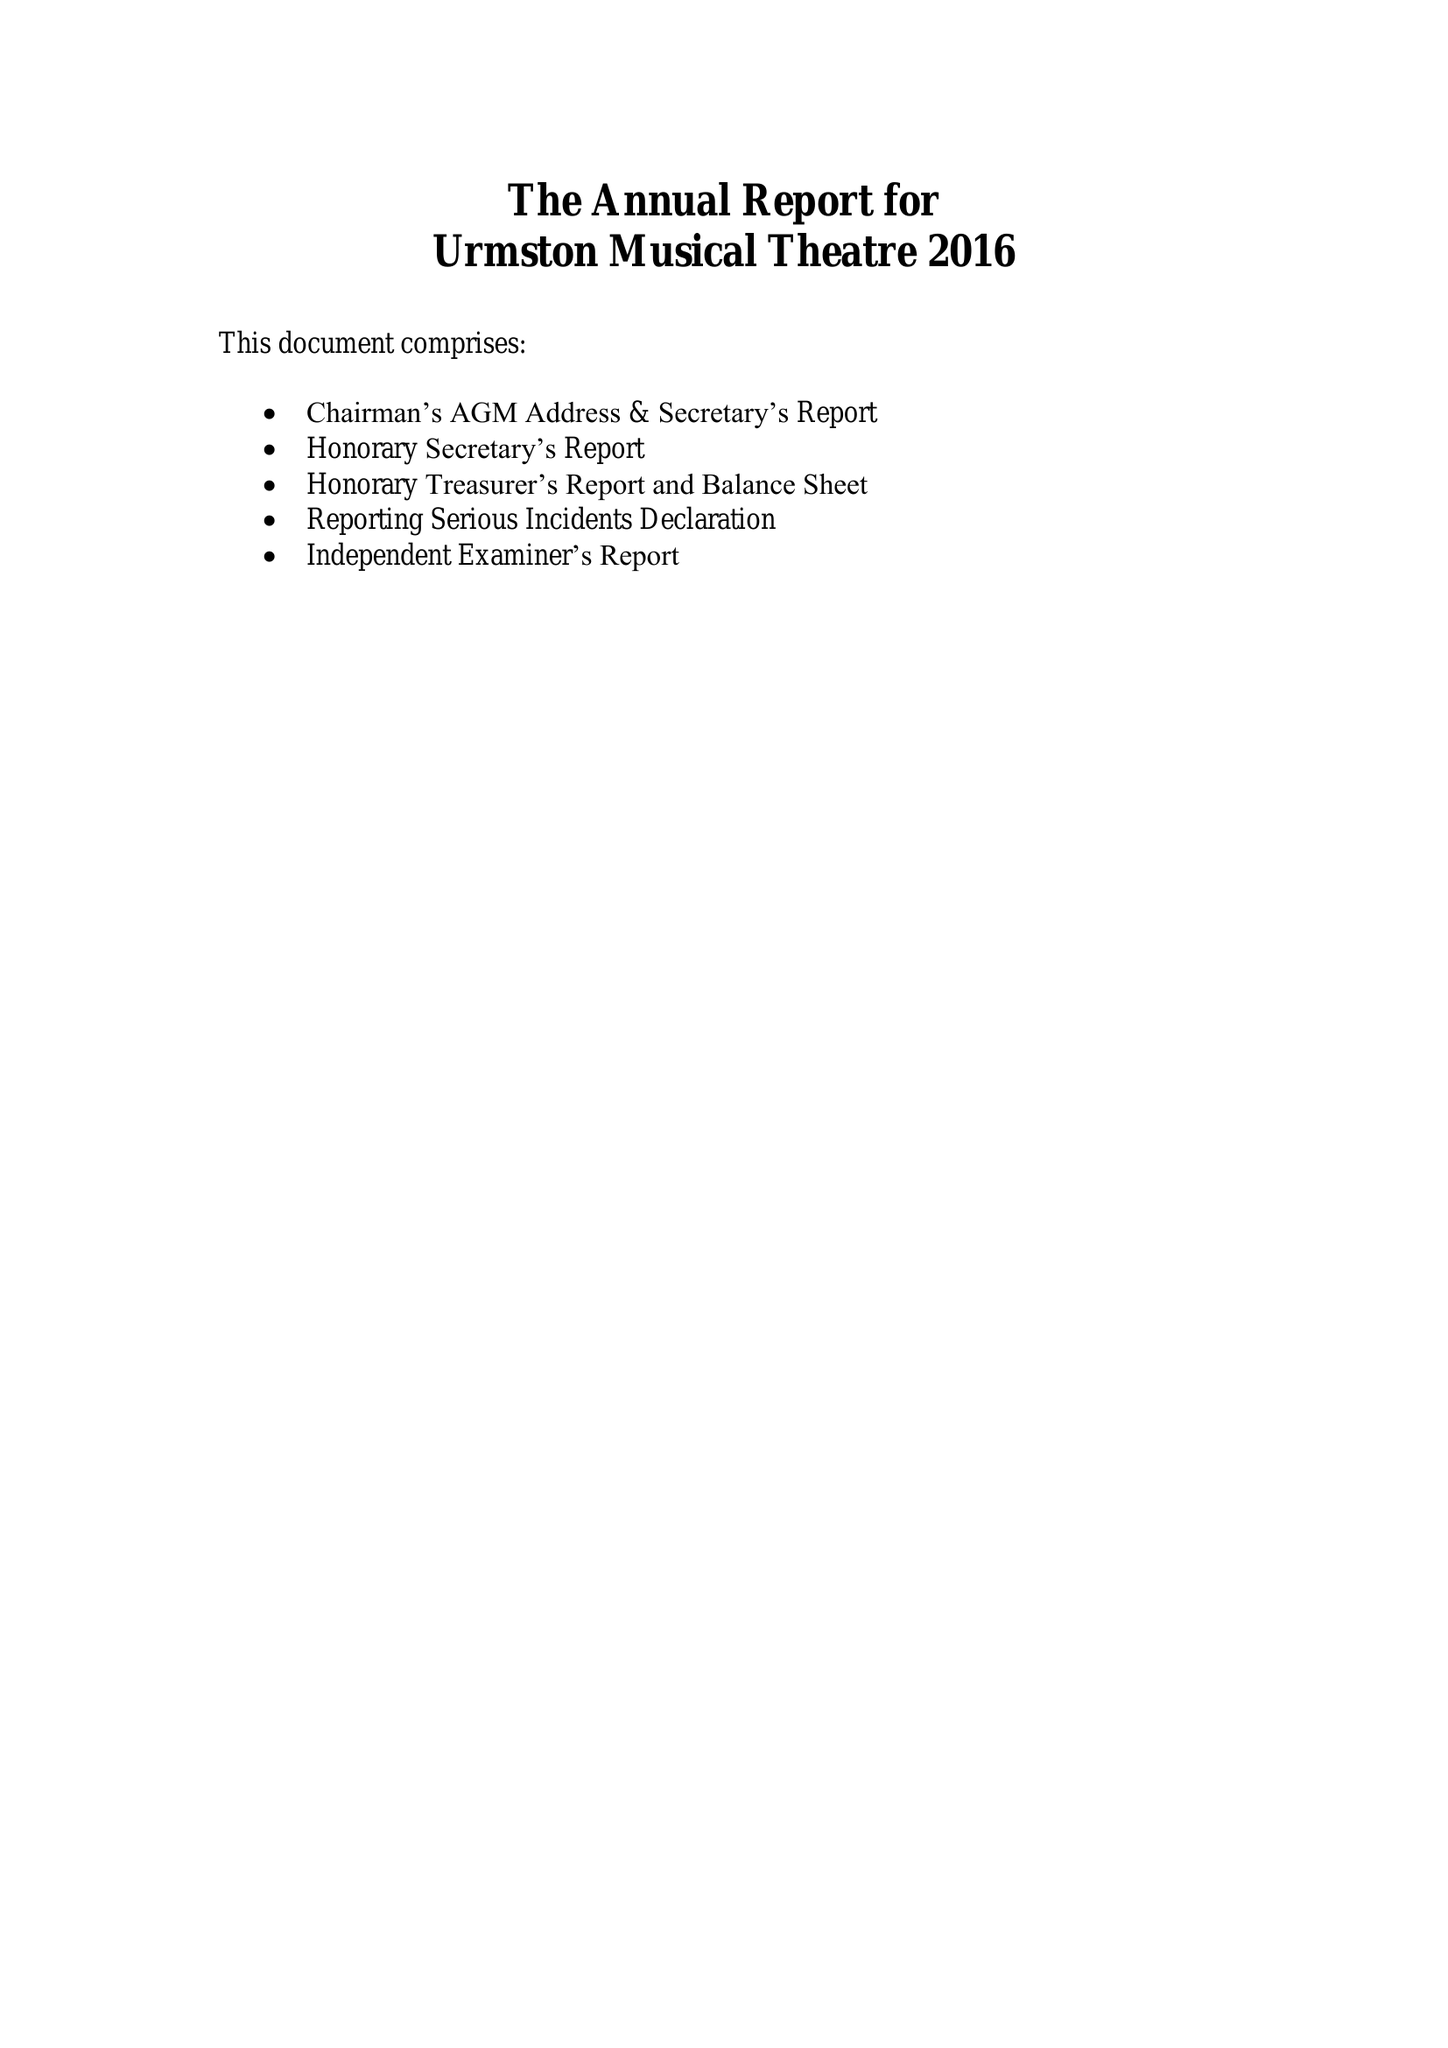What is the value for the charity_name?
Answer the question using a single word or phrase. Urmston Musical Theatre 